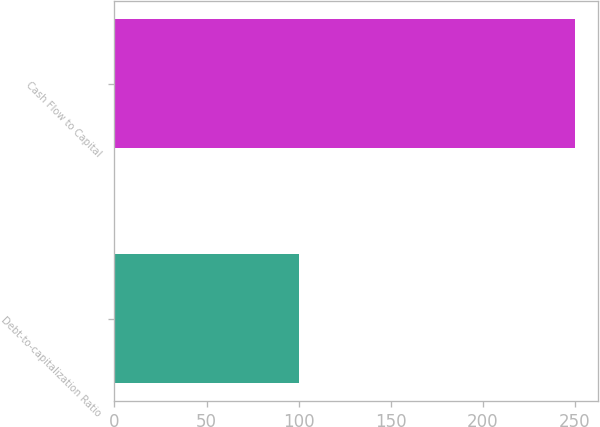Convert chart. <chart><loc_0><loc_0><loc_500><loc_500><bar_chart><fcel>Debt-to-capitalization Ratio<fcel>Cash Flow to Capital<nl><fcel>100<fcel>250<nl></chart> 